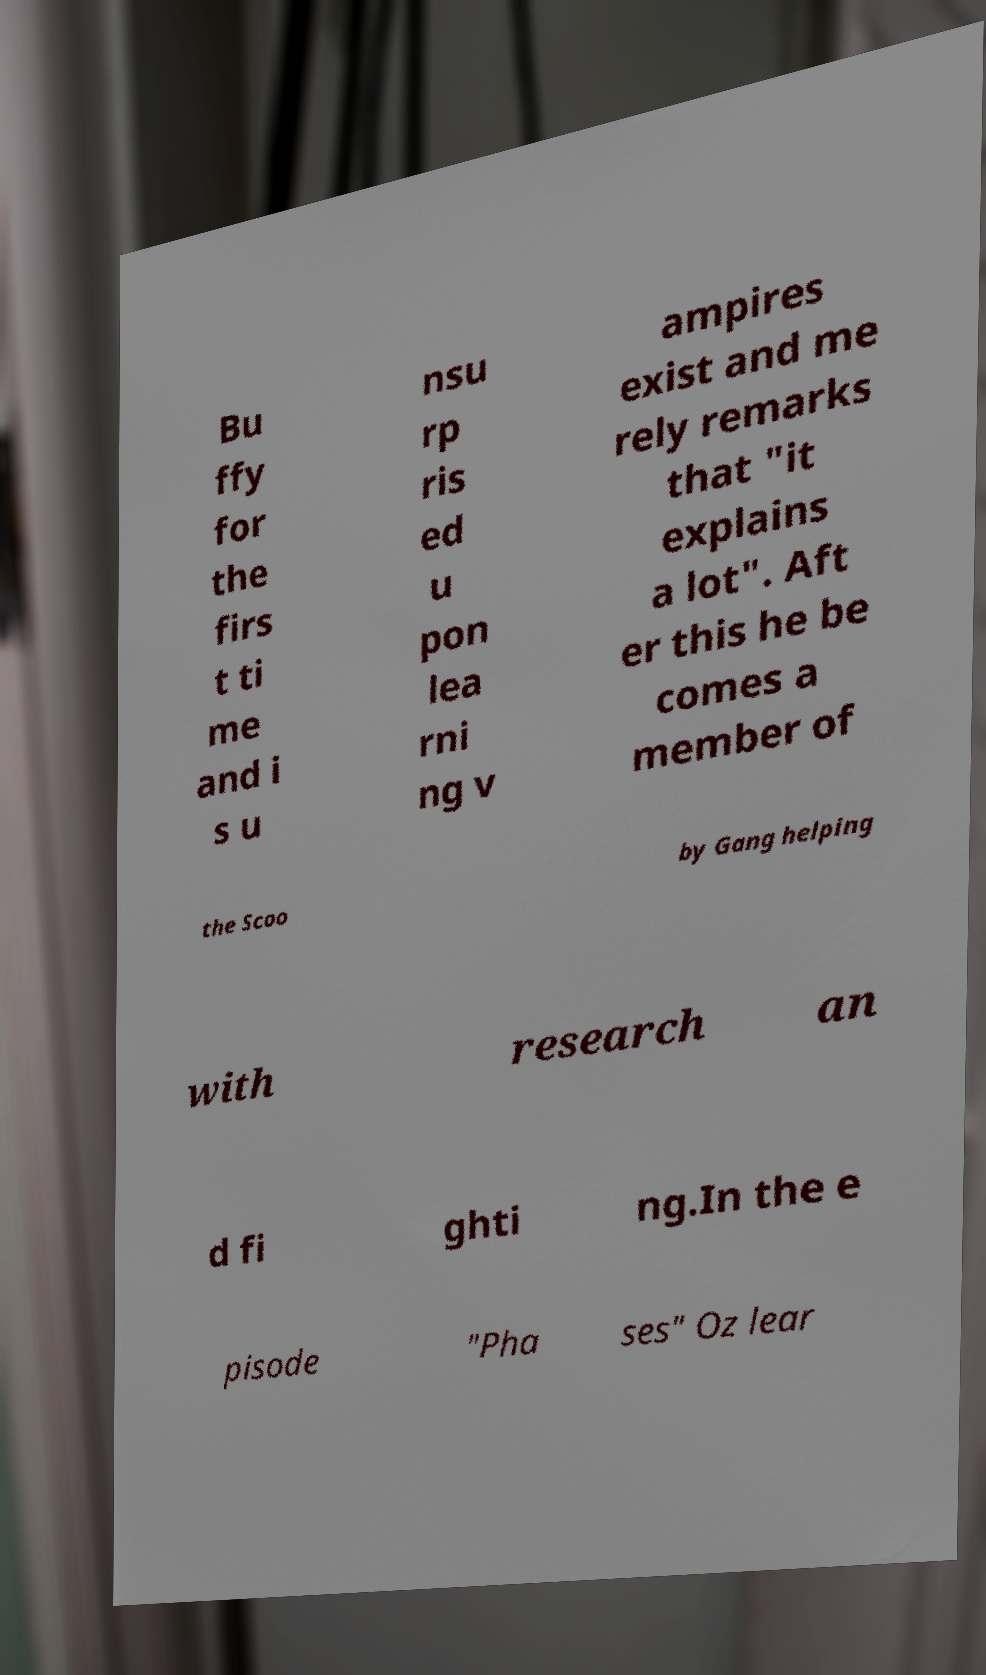There's text embedded in this image that I need extracted. Can you transcribe it verbatim? Bu ffy for the firs t ti me and i s u nsu rp ris ed u pon lea rni ng v ampires exist and me rely remarks that "it explains a lot". Aft er this he be comes a member of the Scoo by Gang helping with research an d fi ghti ng.In the e pisode "Pha ses" Oz lear 